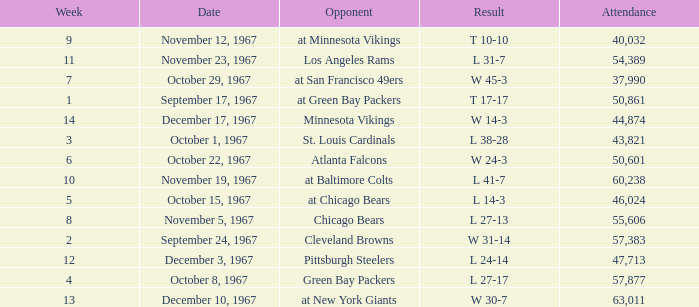Which Date has a Week smaller than 8, and an Opponent of atlanta falcons? October 22, 1967. I'm looking to parse the entire table for insights. Could you assist me with that? {'header': ['Week', 'Date', 'Opponent', 'Result', 'Attendance'], 'rows': [['9', 'November 12, 1967', 'at Minnesota Vikings', 'T 10-10', '40,032'], ['11', 'November 23, 1967', 'Los Angeles Rams', 'L 31-7', '54,389'], ['7', 'October 29, 1967', 'at San Francisco 49ers', 'W 45-3', '37,990'], ['1', 'September 17, 1967', 'at Green Bay Packers', 'T 17-17', '50,861'], ['14', 'December 17, 1967', 'Minnesota Vikings', 'W 14-3', '44,874'], ['3', 'October 1, 1967', 'St. Louis Cardinals', 'L 38-28', '43,821'], ['6', 'October 22, 1967', 'Atlanta Falcons', 'W 24-3', '50,601'], ['10', 'November 19, 1967', 'at Baltimore Colts', 'L 41-7', '60,238'], ['5', 'October 15, 1967', 'at Chicago Bears', 'L 14-3', '46,024'], ['8', 'November 5, 1967', 'Chicago Bears', 'L 27-13', '55,606'], ['2', 'September 24, 1967', 'Cleveland Browns', 'W 31-14', '57,383'], ['12', 'December 3, 1967', 'Pittsburgh Steelers', 'L 24-14', '47,713'], ['4', 'October 8, 1967', 'Green Bay Packers', 'L 27-17', '57,877'], ['13', 'December 10, 1967', 'at New York Giants', 'W 30-7', '63,011']]} 